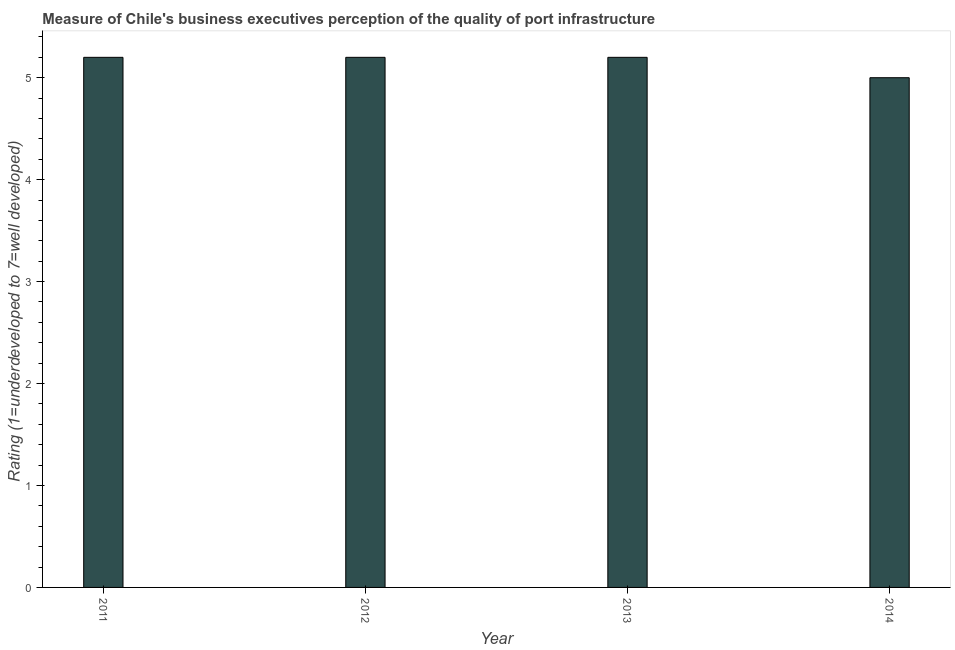Does the graph contain any zero values?
Make the answer very short. No. Does the graph contain grids?
Offer a very short reply. No. What is the title of the graph?
Your response must be concise. Measure of Chile's business executives perception of the quality of port infrastructure. What is the label or title of the Y-axis?
Provide a short and direct response. Rating (1=underdeveloped to 7=well developed) . In which year was the rating measuring quality of port infrastructure maximum?
Keep it short and to the point. 2011. What is the sum of the rating measuring quality of port infrastructure?
Your answer should be compact. 20.6. What is the difference between the rating measuring quality of port infrastructure in 2012 and 2013?
Offer a terse response. 0. What is the average rating measuring quality of port infrastructure per year?
Ensure brevity in your answer.  5.15. Do a majority of the years between 2014 and 2012 (inclusive) have rating measuring quality of port infrastructure greater than 3.6 ?
Your answer should be compact. Yes. What is the ratio of the rating measuring quality of port infrastructure in 2012 to that in 2013?
Provide a succinct answer. 1. Is the difference between the rating measuring quality of port infrastructure in 2012 and 2013 greater than the difference between any two years?
Your response must be concise. No. What is the difference between the highest and the second highest rating measuring quality of port infrastructure?
Ensure brevity in your answer.  0. What is the difference between the highest and the lowest rating measuring quality of port infrastructure?
Provide a succinct answer. 0.2. What is the difference between two consecutive major ticks on the Y-axis?
Provide a short and direct response. 1. Are the values on the major ticks of Y-axis written in scientific E-notation?
Provide a short and direct response. No. What is the difference between the Rating (1=underdeveloped to 7=well developed)  in 2011 and 2014?
Your answer should be compact. 0.2. What is the difference between the Rating (1=underdeveloped to 7=well developed)  in 2012 and 2013?
Make the answer very short. 0. What is the difference between the Rating (1=underdeveloped to 7=well developed)  in 2012 and 2014?
Offer a very short reply. 0.2. What is the difference between the Rating (1=underdeveloped to 7=well developed)  in 2013 and 2014?
Provide a succinct answer. 0.2. What is the ratio of the Rating (1=underdeveloped to 7=well developed)  in 2012 to that in 2014?
Provide a short and direct response. 1.04. What is the ratio of the Rating (1=underdeveloped to 7=well developed)  in 2013 to that in 2014?
Your response must be concise. 1.04. 